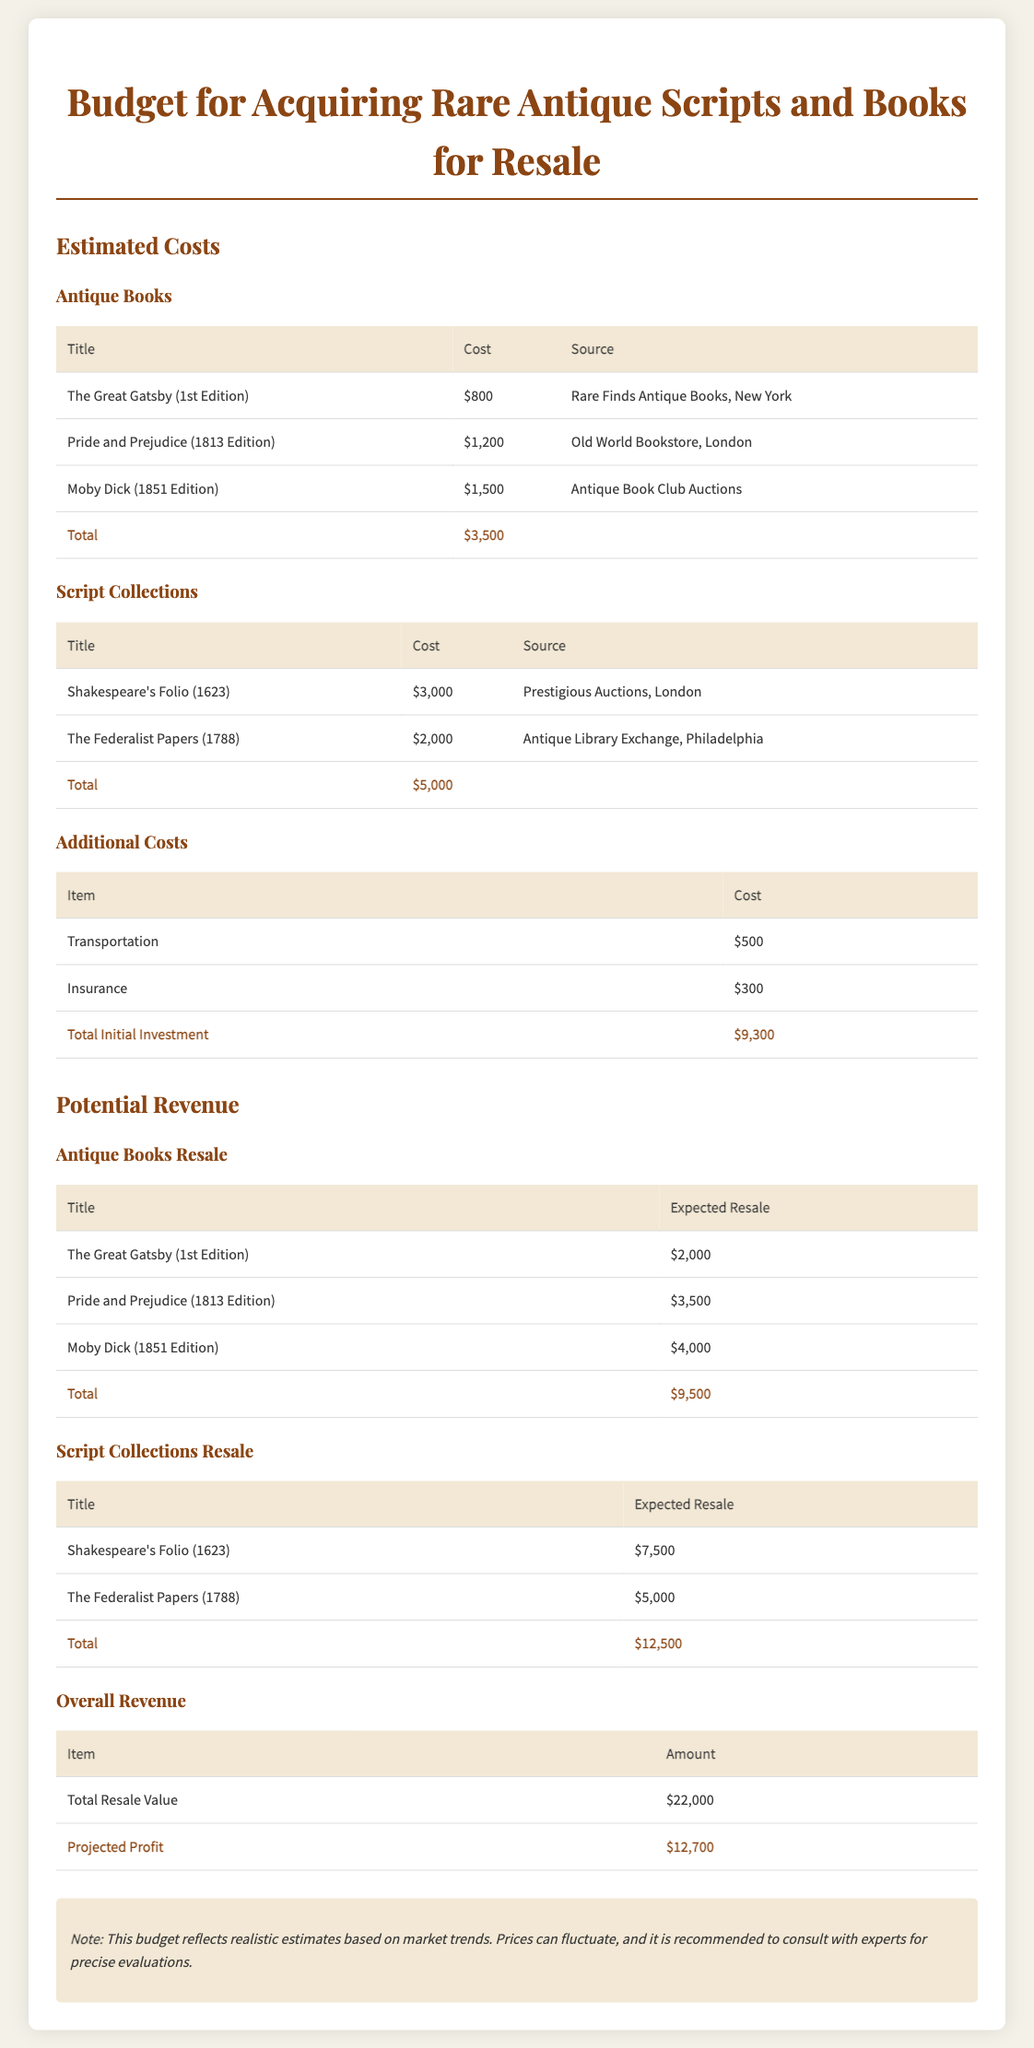What is the total estimated cost for antique books? The total estimated cost for antique books is found in the table under "Estimated Costs" and amounts to $3,500.
Answer: $3,500 What is the expected resale value of Moby Dick (1851 Edition)? The expected resale value for Moby Dick (1851 Edition) is listed under "Antique Books Resale" as $4,000.
Answer: $4,000 What is the total initial investment? The total initial investment is shown in the "Additional Costs" section and is calculated to be $9,300.
Answer: $9,300 Which script collection costs the most? By comparing the costs of the script collections, Shakespeare's Folio (1623) is identified as the most expensive at $3,000.
Answer: $3,000 What is the projected profit? The projected profit can be derived by subtracting the total initial investment from the total resale value, which totals to $12,700.
Answer: $12,700 How much did the Federalist Papers (1788) cost? The cost for the Federalist Papers (1788) is provided in the "Script Collections" section, which shows a price of $2,000.
Answer: $2,000 What is the total expected resale for script collections? The total expected resale for script collections is the sum of the resale values listed, amounting to $12,500.
Answer: $12,500 What is the total revenue from antique books? The total revenue from antique books is the sum of the resale values listed in the relevant section, resulting in $9,500.
Answer: $9,500 What is the cost of insurance? The cost of insurance is detailed under "Additional Costs" and is listed as $300.
Answer: $300 